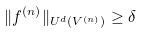<formula> <loc_0><loc_0><loc_500><loc_500>\| f ^ { ( n ) } \| _ { U ^ { d } ( V ^ { ( n ) } ) } \geq \delta</formula> 